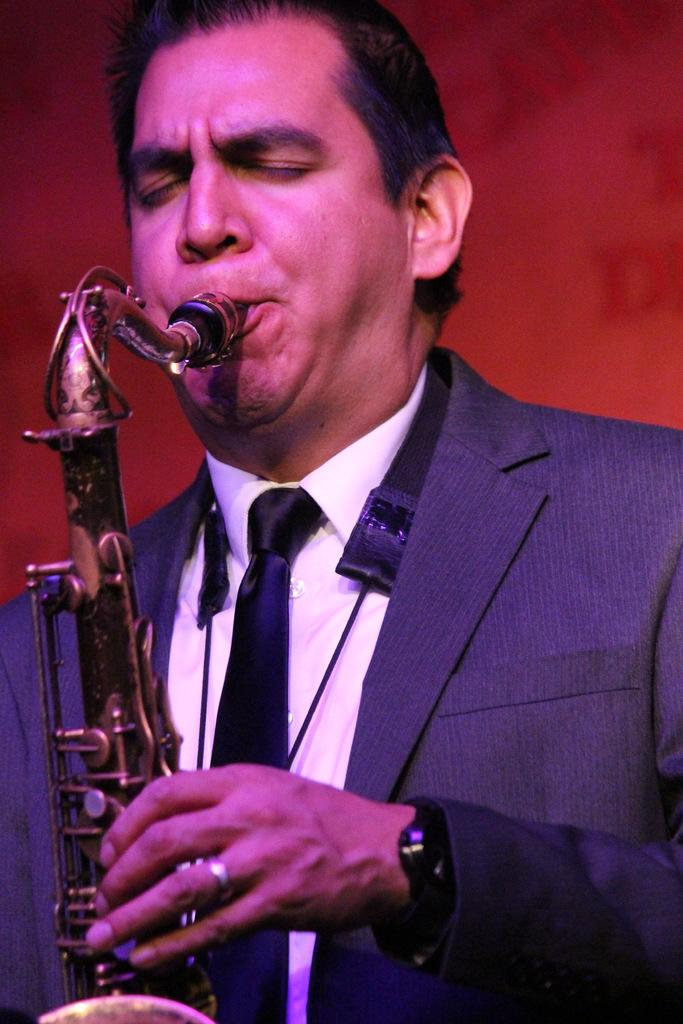What is the main subject of the image? There is a person in the image. What is the person doing in the image? The person is playing a musical instrument. Where is the boat located in the image? There is no boat present in the image. What type of recess can be seen in the image? There is no recess present in the image. 